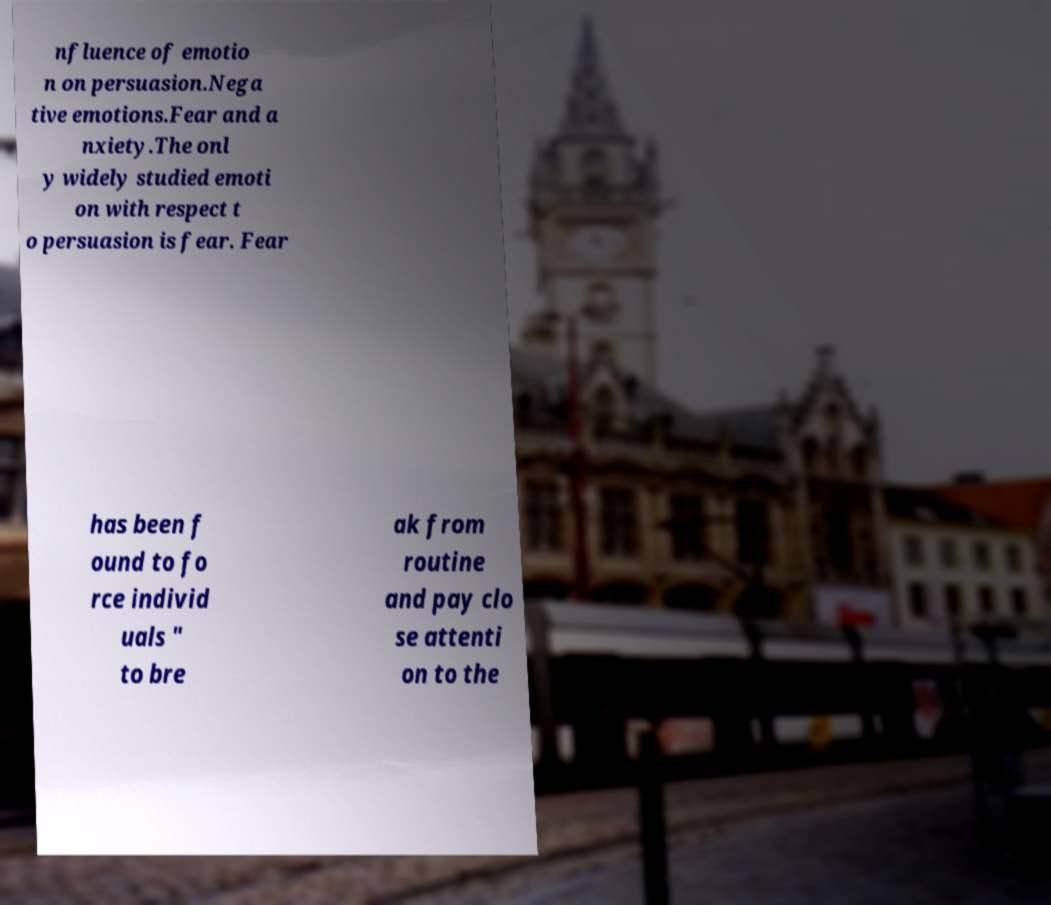Could you extract and type out the text from this image? nfluence of emotio n on persuasion.Nega tive emotions.Fear and a nxiety.The onl y widely studied emoti on with respect t o persuasion is fear. Fear has been f ound to fo rce individ uals " to bre ak from routine and pay clo se attenti on to the 